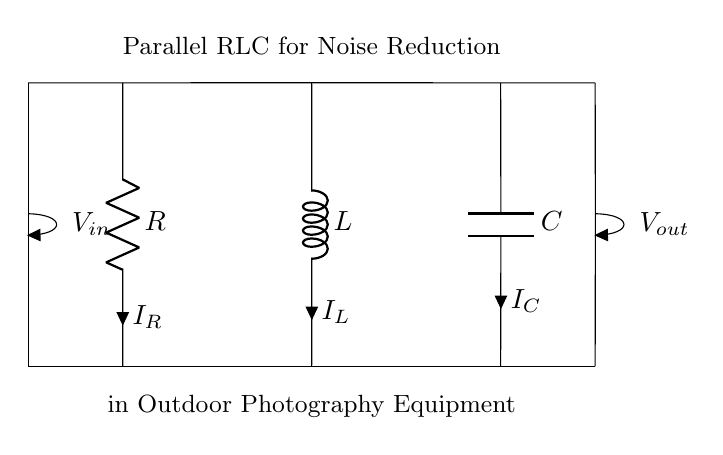What are the components in this circuit? The circuit contains a resistor, an inductor, and a capacitor, which are the basic elements used in an RLC circuit. These components are clearly labeled R, L, and C in the diagram.
Answer: Resistor, inductor, capacitor What is the configuration of the RLC components? The circuit is a parallel configuration, meaning that the resistor, inductor, and capacitor are all connected across the same two nodes, allowing each component to share the same voltage across them.
Answer: Parallel What does V in represent in this circuit? V in represents the input voltage applied across the entire parallel RLC configuration, and it is the voltage that drives the current through each component simultaneously.
Answer: Input voltage Which component has the current labeled as I R? The current labeled as I R flows through the resistor, as indicated by the labeling next to that component in the circuit diagram.
Answer: Resistor What is the role of this parallel RLC circuit in outdoor photography equipment? The parallel RLC circuit is used for noise reduction, helping to filter out unwanted electrical noise and stabilize the signal in the outdoor photography equipment, enhancing the quality of photos taken in varying environmental conditions.
Answer: Noise reduction What is the relationship between the components in this circuit for filtering purposes? In a parallel RLC circuit, the inductor and capacitor work together to filter frequencies; the inductor reacts to changes in current while the capacitor reacts to changes in voltage, creating a resonant effect that can reduce specific noise frequencies while allowing others to pass through.
Answer: Filtering frequencies How does the parallel RLC circuit improve the signal quality in outdoor photography? This circuit improves signal quality by reducing electromagnetic interference and other noise sources, thus stabilizing the output signal for better performance of the photography equipment, especially in challenging outdoor conditions.
Answer: Improved signal quality 